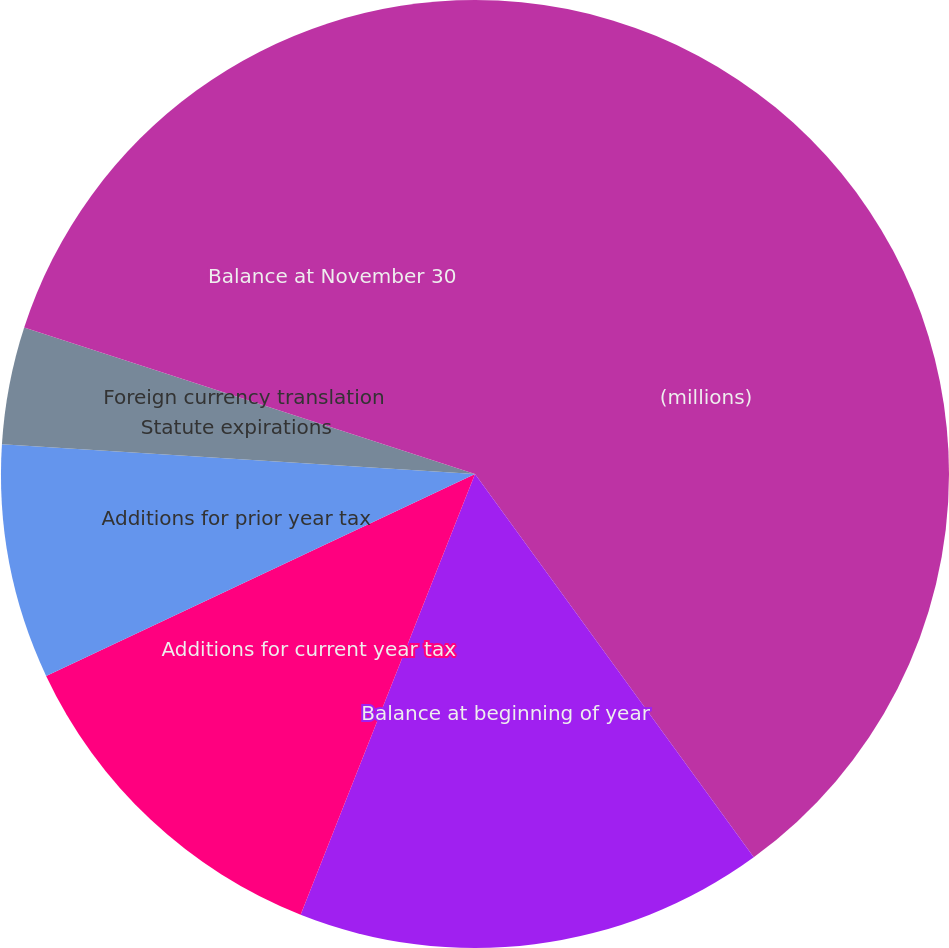Convert chart. <chart><loc_0><loc_0><loc_500><loc_500><pie_chart><fcel>(millions)<fcel>Balance at beginning of year<fcel>Additions for current year tax<fcel>Additions for prior year tax<fcel>Statute expirations<fcel>Foreign currency translation<fcel>Balance at November 30<nl><fcel>39.99%<fcel>16.0%<fcel>12.0%<fcel>8.0%<fcel>4.0%<fcel>0.0%<fcel>20.0%<nl></chart> 